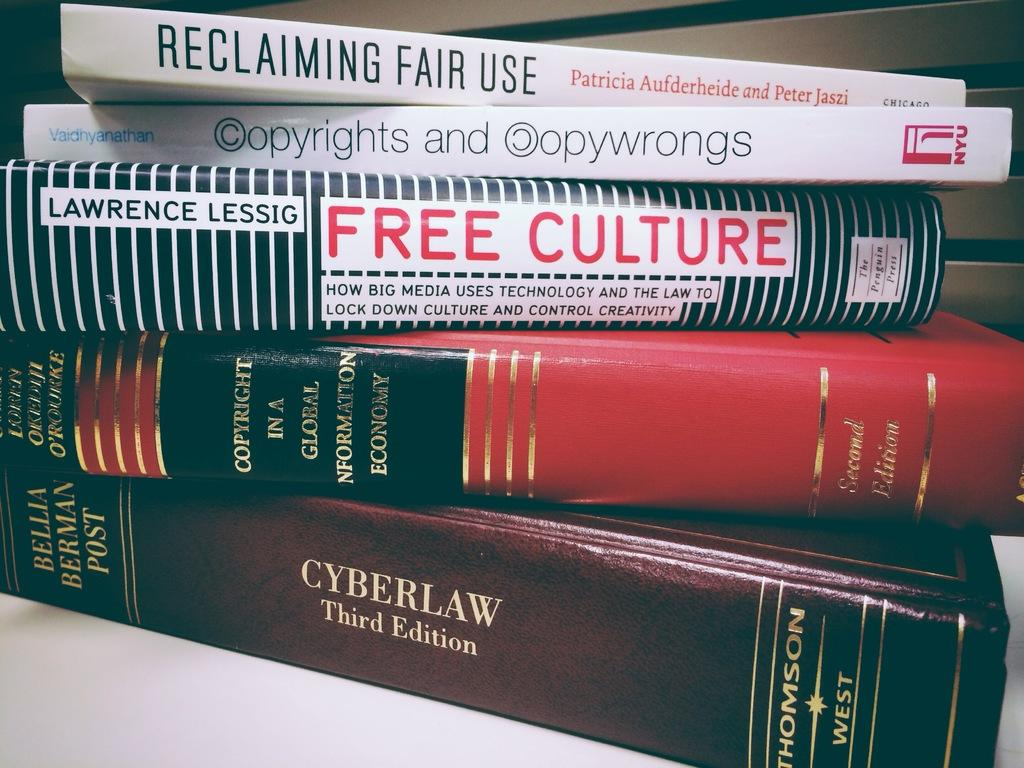<image>
Write a terse but informative summary of the picture. Five textbooks are on a table, one of the books is Free Culture by Lawrence Lessig. 